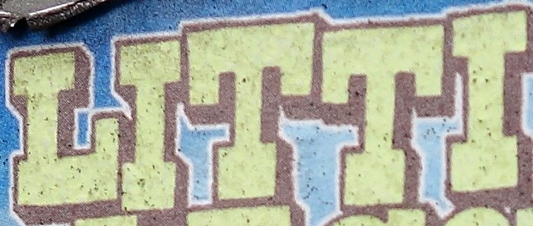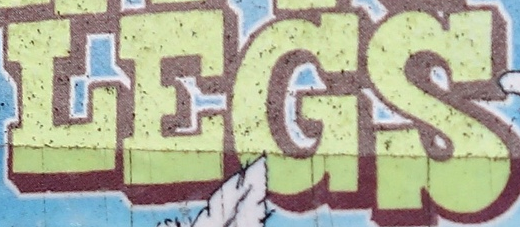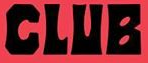Identify the words shown in these images in order, separated by a semicolon. LITTI; LEGS; CLUB 